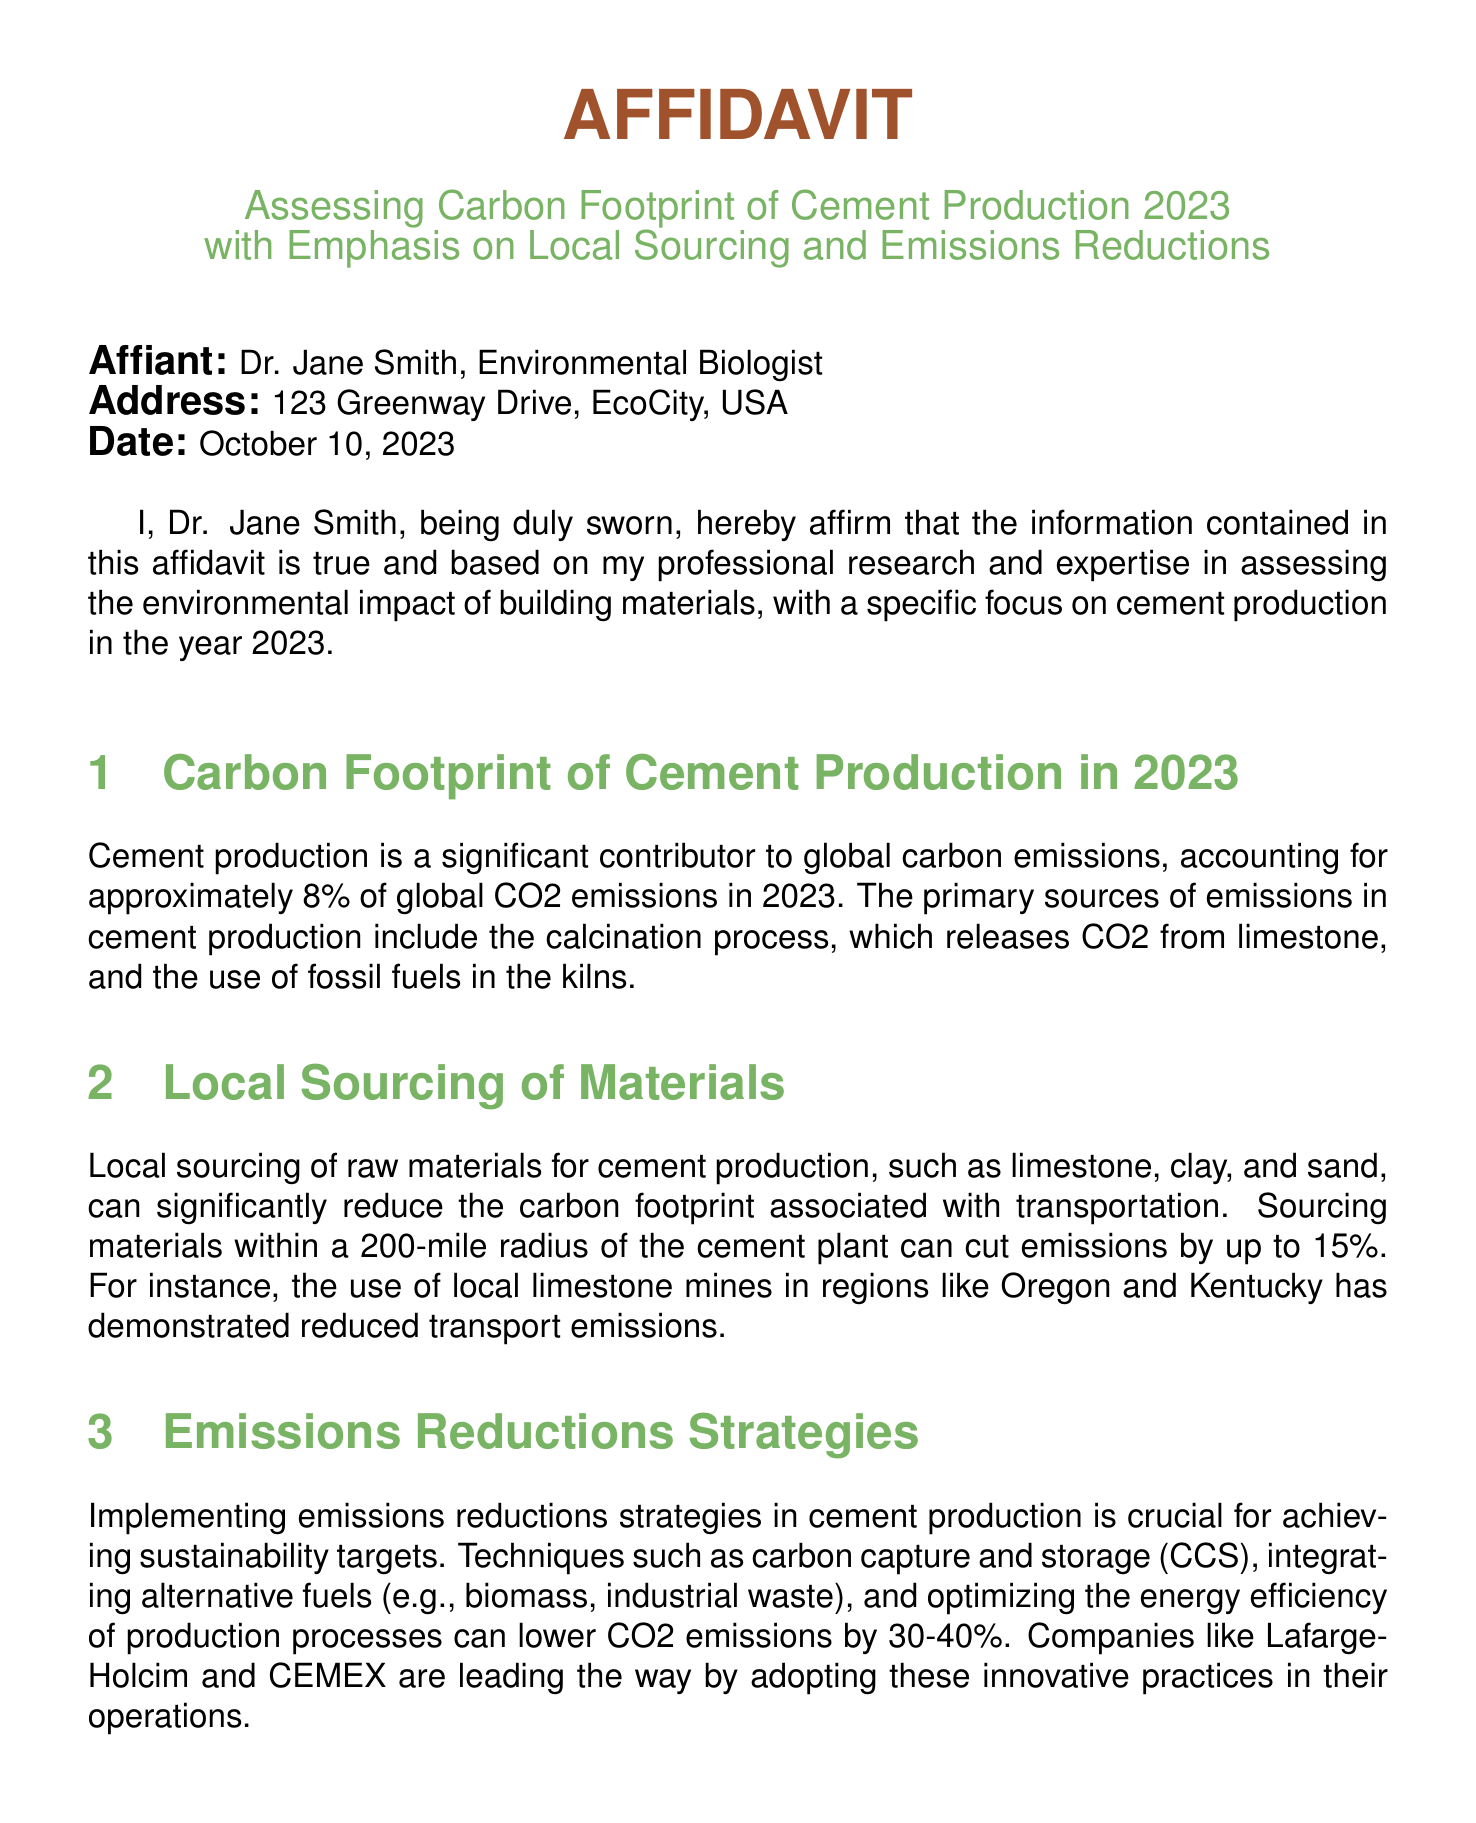What is the title of the affidavit? The title is specified at the beginning of the document in a prominent position.
Answer: AFFIDAVIT Who is the affiant? The affiant's name is mentioned in the introductory section of the document.
Answer: Dr. Jane Smith What date was the affidavit signed? The date is indicated in the section following the affiant information.
Answer: October 10, 2023 What is the approximate percentage of global CO2 emissions attributed to cement production in 2023? This information is provided in the section discussing the carbon footprint of cement production.
Answer: 8% What strategies can lower CO2 emissions by 30-40% in cement production? This is mentioned in the section on emissions reduction strategies, indicating specific techniques.
Answer: Carbon capture and storage Within what radius can sourcing local materials cut emissions by up to 15%? This detail is found in the local sourcing section, specifying the distance.
Answer: 200-mile radius Which companies are mentioned as leaders in emissions reduction practices? The document refers to specific companies in the emissions reduction strategies section.
Answer: LafargeHolcim and CEMEX How do reduced CO2 emissions impact public health? The document discusses the environmental and health impacts in a dedicated section.
Answer: Improved air quality What types of alternative fuels are suggested for emissions reductions? This is outlined in the emissions reduction strategies section, listing specific fuel types.
Answer: Biomass, industrial waste 